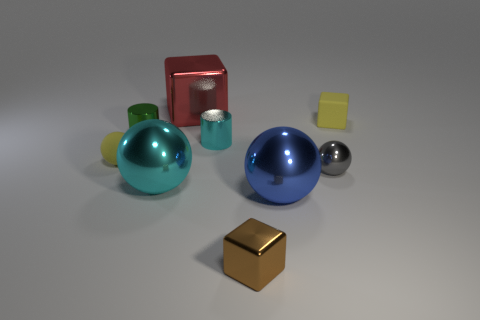What is the color of the tiny rubber object that is the same shape as the large blue thing?
Give a very brief answer. Yellow. What number of tiny matte balls are the same color as the tiny rubber cube?
Make the answer very short. 1. There is a small metal cylinder to the right of the large metallic thing that is behind the cyan metal thing in front of the gray thing; what is its color?
Ensure brevity in your answer.  Cyan. Do the tiny brown block and the green thing have the same material?
Your response must be concise. Yes. Does the tiny brown metal object have the same shape as the tiny cyan shiny thing?
Keep it short and to the point. No. Is the number of tiny cyan metallic cylinders to the left of the small cyan cylinder the same as the number of matte blocks in front of the blue thing?
Offer a terse response. Yes. The big block that is the same material as the green object is what color?
Offer a terse response. Red. How many small gray objects have the same material as the big cyan sphere?
Make the answer very short. 1. Is the color of the shiny object left of the cyan metal sphere the same as the small rubber sphere?
Your answer should be very brief. No. What number of small yellow things have the same shape as the brown shiny thing?
Provide a short and direct response. 1. 